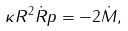Convert formula to latex. <formula><loc_0><loc_0><loc_500><loc_500>\kappa R ^ { 2 } \dot { R } p = - 2 \dot { M } ,</formula> 